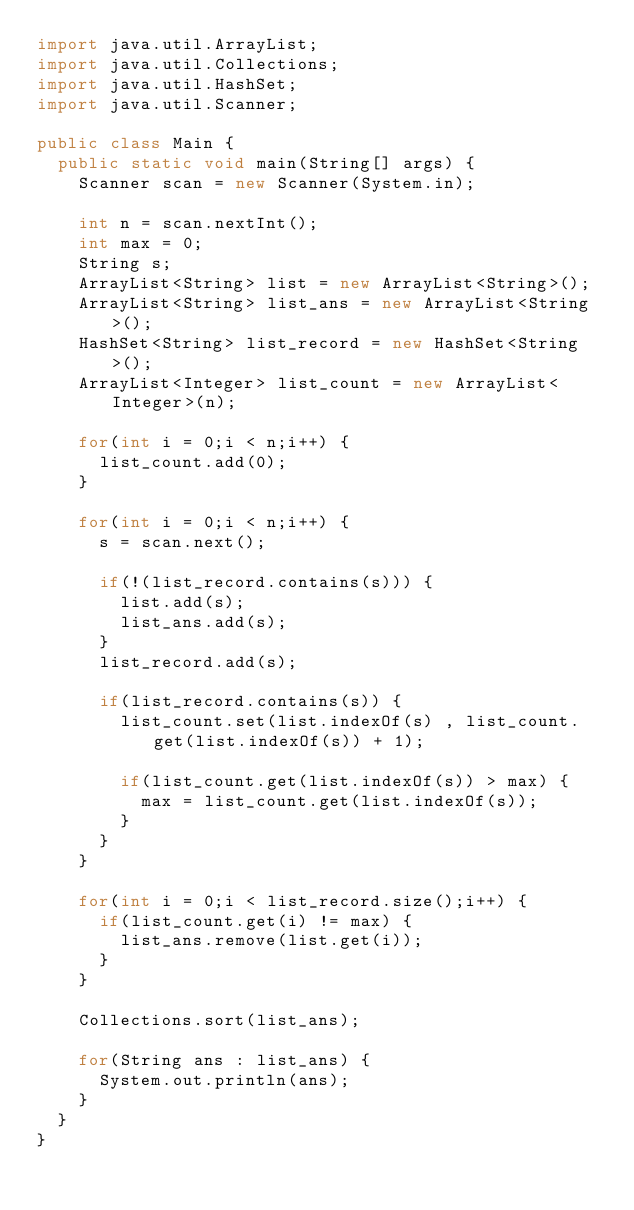<code> <loc_0><loc_0><loc_500><loc_500><_Java_>import java.util.ArrayList;
import java.util.Collections;
import java.util.HashSet;
import java.util.Scanner;

public class Main {
	public static void main(String[] args) {
		Scanner scan = new Scanner(System.in);

		int n = scan.nextInt();
		int max = 0;
		String s;
		ArrayList<String> list = new ArrayList<String>();
		ArrayList<String> list_ans = new ArrayList<String>();
		HashSet<String> list_record = new HashSet<String>();
		ArrayList<Integer> list_count = new ArrayList<Integer>(n);

		for(int i = 0;i < n;i++) {
			list_count.add(0);
		}

		for(int i = 0;i < n;i++) {
			s = scan.next();

			if(!(list_record.contains(s))) {
				list.add(s);
				list_ans.add(s);
			}
			list_record.add(s);

			if(list_record.contains(s)) {
				list_count.set(list.indexOf(s) , list_count.get(list.indexOf(s)) + 1);

				if(list_count.get(list.indexOf(s)) > max) {
					max = list_count.get(list.indexOf(s));
				}
			}
		}

		for(int i = 0;i < list_record.size();i++) {
			if(list_count.get(i) != max) {
				list_ans.remove(list.get(i));
			}
		}

		Collections.sort(list_ans);

		for(String ans : list_ans) {
			System.out.println(ans);
		}
	}
}</code> 